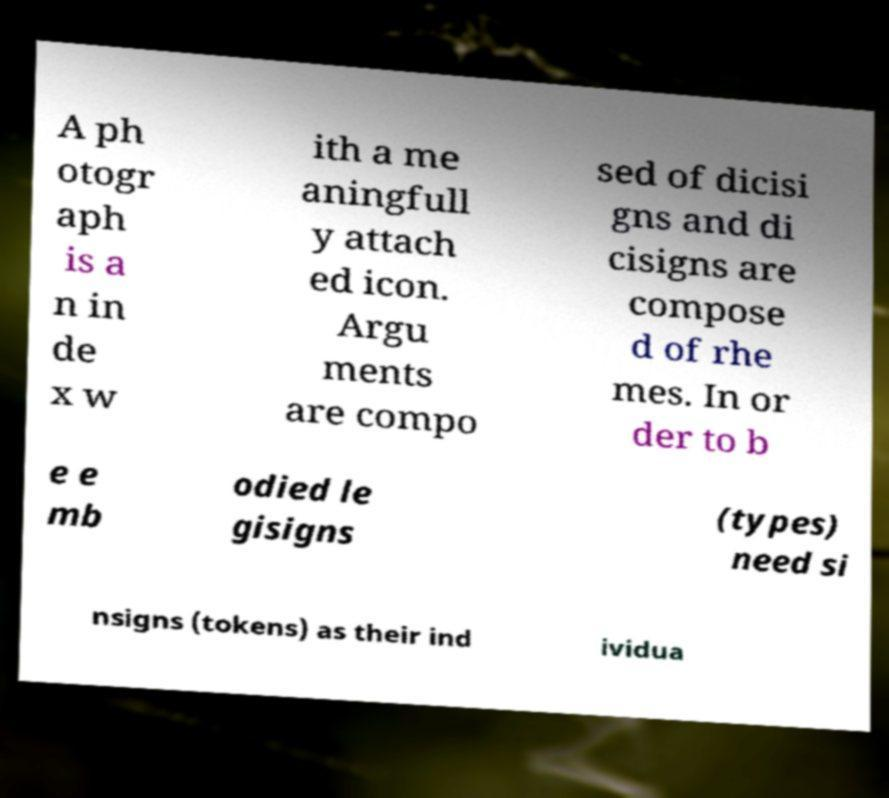Can you accurately transcribe the text from the provided image for me? A ph otogr aph is a n in de x w ith a me aningfull y attach ed icon. Argu ments are compo sed of dicisi gns and di cisigns are compose d of rhe mes. In or der to b e e mb odied le gisigns (types) need si nsigns (tokens) as their ind ividua 